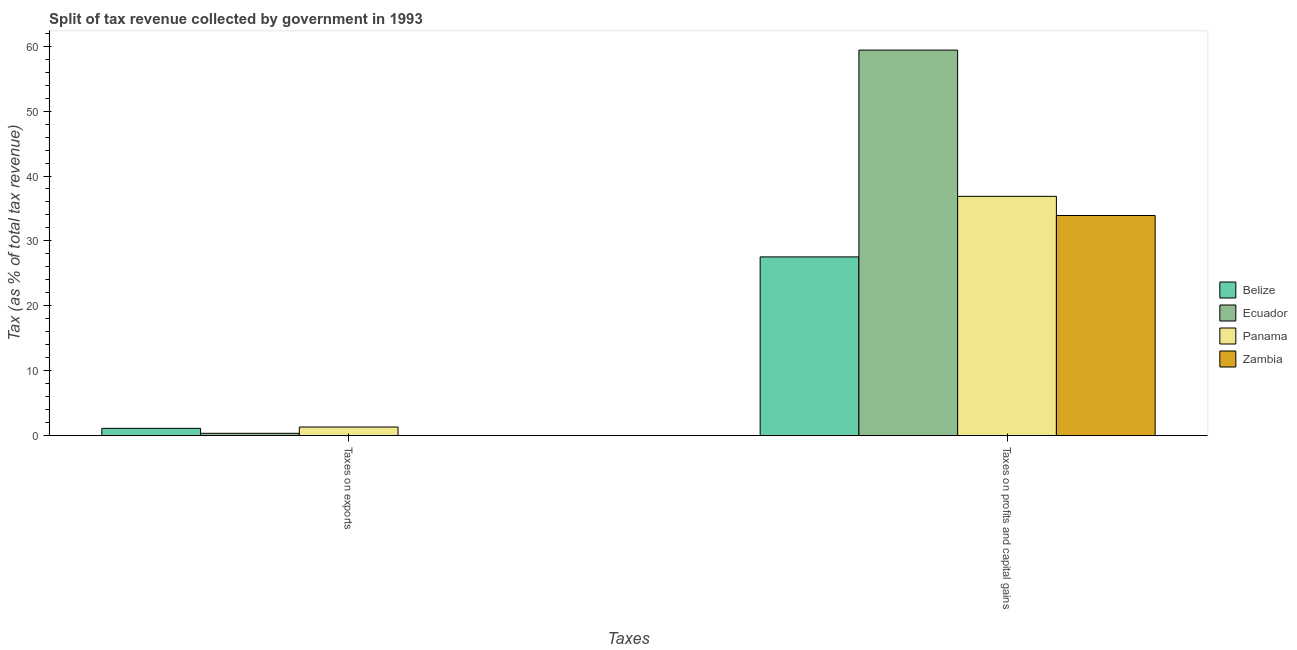How many different coloured bars are there?
Give a very brief answer. 4. How many groups of bars are there?
Give a very brief answer. 2. Are the number of bars on each tick of the X-axis equal?
Ensure brevity in your answer.  Yes. What is the label of the 1st group of bars from the left?
Give a very brief answer. Taxes on exports. What is the percentage of revenue obtained from taxes on profits and capital gains in Ecuador?
Give a very brief answer. 59.4. Across all countries, what is the maximum percentage of revenue obtained from taxes on profits and capital gains?
Make the answer very short. 59.4. Across all countries, what is the minimum percentage of revenue obtained from taxes on exports?
Offer a very short reply. 0.01. In which country was the percentage of revenue obtained from taxes on profits and capital gains maximum?
Offer a very short reply. Ecuador. In which country was the percentage of revenue obtained from taxes on profits and capital gains minimum?
Offer a very short reply. Belize. What is the total percentage of revenue obtained from taxes on profits and capital gains in the graph?
Provide a succinct answer. 157.71. What is the difference between the percentage of revenue obtained from taxes on exports in Panama and that in Ecuador?
Offer a very short reply. 0.97. What is the difference between the percentage of revenue obtained from taxes on exports in Belize and the percentage of revenue obtained from taxes on profits and capital gains in Panama?
Ensure brevity in your answer.  -35.74. What is the average percentage of revenue obtained from taxes on exports per country?
Your response must be concise. 0.7. What is the difference between the percentage of revenue obtained from taxes on profits and capital gains and percentage of revenue obtained from taxes on exports in Ecuador?
Make the answer very short. 59.04. In how many countries, is the percentage of revenue obtained from taxes on exports greater than 26 %?
Make the answer very short. 0. What is the ratio of the percentage of revenue obtained from taxes on profits and capital gains in Belize to that in Panama?
Keep it short and to the point. 0.75. In how many countries, is the percentage of revenue obtained from taxes on profits and capital gains greater than the average percentage of revenue obtained from taxes on profits and capital gains taken over all countries?
Your answer should be compact. 1. What does the 3rd bar from the left in Taxes on profits and capital gains represents?
Make the answer very short. Panama. What does the 3rd bar from the right in Taxes on profits and capital gains represents?
Make the answer very short. Ecuador. Are all the bars in the graph horizontal?
Provide a succinct answer. No. Are the values on the major ticks of Y-axis written in scientific E-notation?
Your answer should be compact. No. Does the graph contain any zero values?
Your answer should be compact. No. Does the graph contain grids?
Ensure brevity in your answer.  No. How many legend labels are there?
Offer a terse response. 4. What is the title of the graph?
Your answer should be compact. Split of tax revenue collected by government in 1993. What is the label or title of the X-axis?
Your response must be concise. Taxes. What is the label or title of the Y-axis?
Your answer should be compact. Tax (as % of total tax revenue). What is the Tax (as % of total tax revenue) in Belize in Taxes on exports?
Your answer should be very brief. 1.12. What is the Tax (as % of total tax revenue) of Ecuador in Taxes on exports?
Keep it short and to the point. 0.36. What is the Tax (as % of total tax revenue) in Panama in Taxes on exports?
Provide a succinct answer. 1.33. What is the Tax (as % of total tax revenue) of Zambia in Taxes on exports?
Provide a short and direct response. 0.01. What is the Tax (as % of total tax revenue) in Belize in Taxes on profits and capital gains?
Offer a very short reply. 27.54. What is the Tax (as % of total tax revenue) of Ecuador in Taxes on profits and capital gains?
Offer a very short reply. 59.4. What is the Tax (as % of total tax revenue) of Panama in Taxes on profits and capital gains?
Provide a short and direct response. 36.86. What is the Tax (as % of total tax revenue) of Zambia in Taxes on profits and capital gains?
Your response must be concise. 33.92. Across all Taxes, what is the maximum Tax (as % of total tax revenue) of Belize?
Your answer should be compact. 27.54. Across all Taxes, what is the maximum Tax (as % of total tax revenue) of Ecuador?
Give a very brief answer. 59.4. Across all Taxes, what is the maximum Tax (as % of total tax revenue) of Panama?
Give a very brief answer. 36.86. Across all Taxes, what is the maximum Tax (as % of total tax revenue) of Zambia?
Provide a short and direct response. 33.92. Across all Taxes, what is the minimum Tax (as % of total tax revenue) of Belize?
Ensure brevity in your answer.  1.12. Across all Taxes, what is the minimum Tax (as % of total tax revenue) of Ecuador?
Make the answer very short. 0.36. Across all Taxes, what is the minimum Tax (as % of total tax revenue) of Panama?
Make the answer very short. 1.33. Across all Taxes, what is the minimum Tax (as % of total tax revenue) in Zambia?
Your answer should be very brief. 0.01. What is the total Tax (as % of total tax revenue) of Belize in the graph?
Your answer should be compact. 28.66. What is the total Tax (as % of total tax revenue) in Ecuador in the graph?
Ensure brevity in your answer.  59.76. What is the total Tax (as % of total tax revenue) of Panama in the graph?
Your response must be concise. 38.19. What is the total Tax (as % of total tax revenue) in Zambia in the graph?
Your response must be concise. 33.92. What is the difference between the Tax (as % of total tax revenue) in Belize in Taxes on exports and that in Taxes on profits and capital gains?
Make the answer very short. -26.41. What is the difference between the Tax (as % of total tax revenue) in Ecuador in Taxes on exports and that in Taxes on profits and capital gains?
Ensure brevity in your answer.  -59.04. What is the difference between the Tax (as % of total tax revenue) in Panama in Taxes on exports and that in Taxes on profits and capital gains?
Offer a very short reply. -35.54. What is the difference between the Tax (as % of total tax revenue) in Zambia in Taxes on exports and that in Taxes on profits and capital gains?
Your answer should be compact. -33.91. What is the difference between the Tax (as % of total tax revenue) in Belize in Taxes on exports and the Tax (as % of total tax revenue) in Ecuador in Taxes on profits and capital gains?
Offer a very short reply. -58.27. What is the difference between the Tax (as % of total tax revenue) of Belize in Taxes on exports and the Tax (as % of total tax revenue) of Panama in Taxes on profits and capital gains?
Your answer should be compact. -35.74. What is the difference between the Tax (as % of total tax revenue) of Belize in Taxes on exports and the Tax (as % of total tax revenue) of Zambia in Taxes on profits and capital gains?
Provide a short and direct response. -32.8. What is the difference between the Tax (as % of total tax revenue) of Ecuador in Taxes on exports and the Tax (as % of total tax revenue) of Panama in Taxes on profits and capital gains?
Give a very brief answer. -36.51. What is the difference between the Tax (as % of total tax revenue) of Ecuador in Taxes on exports and the Tax (as % of total tax revenue) of Zambia in Taxes on profits and capital gains?
Make the answer very short. -33.56. What is the difference between the Tax (as % of total tax revenue) of Panama in Taxes on exports and the Tax (as % of total tax revenue) of Zambia in Taxes on profits and capital gains?
Keep it short and to the point. -32.59. What is the average Tax (as % of total tax revenue) in Belize per Taxes?
Keep it short and to the point. 14.33. What is the average Tax (as % of total tax revenue) in Ecuador per Taxes?
Your answer should be compact. 29.88. What is the average Tax (as % of total tax revenue) of Panama per Taxes?
Give a very brief answer. 19.1. What is the average Tax (as % of total tax revenue) in Zambia per Taxes?
Your answer should be very brief. 16.96. What is the difference between the Tax (as % of total tax revenue) of Belize and Tax (as % of total tax revenue) of Ecuador in Taxes on exports?
Ensure brevity in your answer.  0.76. What is the difference between the Tax (as % of total tax revenue) in Belize and Tax (as % of total tax revenue) in Panama in Taxes on exports?
Make the answer very short. -0.21. What is the difference between the Tax (as % of total tax revenue) in Belize and Tax (as % of total tax revenue) in Zambia in Taxes on exports?
Offer a terse response. 1.12. What is the difference between the Tax (as % of total tax revenue) of Ecuador and Tax (as % of total tax revenue) of Panama in Taxes on exports?
Make the answer very short. -0.97. What is the difference between the Tax (as % of total tax revenue) of Ecuador and Tax (as % of total tax revenue) of Zambia in Taxes on exports?
Provide a short and direct response. 0.35. What is the difference between the Tax (as % of total tax revenue) in Panama and Tax (as % of total tax revenue) in Zambia in Taxes on exports?
Make the answer very short. 1.32. What is the difference between the Tax (as % of total tax revenue) of Belize and Tax (as % of total tax revenue) of Ecuador in Taxes on profits and capital gains?
Your answer should be very brief. -31.86. What is the difference between the Tax (as % of total tax revenue) of Belize and Tax (as % of total tax revenue) of Panama in Taxes on profits and capital gains?
Provide a succinct answer. -9.33. What is the difference between the Tax (as % of total tax revenue) in Belize and Tax (as % of total tax revenue) in Zambia in Taxes on profits and capital gains?
Make the answer very short. -6.38. What is the difference between the Tax (as % of total tax revenue) in Ecuador and Tax (as % of total tax revenue) in Panama in Taxes on profits and capital gains?
Ensure brevity in your answer.  22.53. What is the difference between the Tax (as % of total tax revenue) of Ecuador and Tax (as % of total tax revenue) of Zambia in Taxes on profits and capital gains?
Ensure brevity in your answer.  25.48. What is the difference between the Tax (as % of total tax revenue) in Panama and Tax (as % of total tax revenue) in Zambia in Taxes on profits and capital gains?
Offer a terse response. 2.95. What is the ratio of the Tax (as % of total tax revenue) of Belize in Taxes on exports to that in Taxes on profits and capital gains?
Offer a very short reply. 0.04. What is the ratio of the Tax (as % of total tax revenue) of Ecuador in Taxes on exports to that in Taxes on profits and capital gains?
Keep it short and to the point. 0.01. What is the ratio of the Tax (as % of total tax revenue) in Panama in Taxes on exports to that in Taxes on profits and capital gains?
Provide a succinct answer. 0.04. What is the difference between the highest and the second highest Tax (as % of total tax revenue) in Belize?
Provide a succinct answer. 26.41. What is the difference between the highest and the second highest Tax (as % of total tax revenue) in Ecuador?
Ensure brevity in your answer.  59.04. What is the difference between the highest and the second highest Tax (as % of total tax revenue) in Panama?
Give a very brief answer. 35.54. What is the difference between the highest and the second highest Tax (as % of total tax revenue) of Zambia?
Provide a short and direct response. 33.91. What is the difference between the highest and the lowest Tax (as % of total tax revenue) in Belize?
Make the answer very short. 26.41. What is the difference between the highest and the lowest Tax (as % of total tax revenue) of Ecuador?
Provide a succinct answer. 59.04. What is the difference between the highest and the lowest Tax (as % of total tax revenue) of Panama?
Make the answer very short. 35.54. What is the difference between the highest and the lowest Tax (as % of total tax revenue) in Zambia?
Provide a succinct answer. 33.91. 